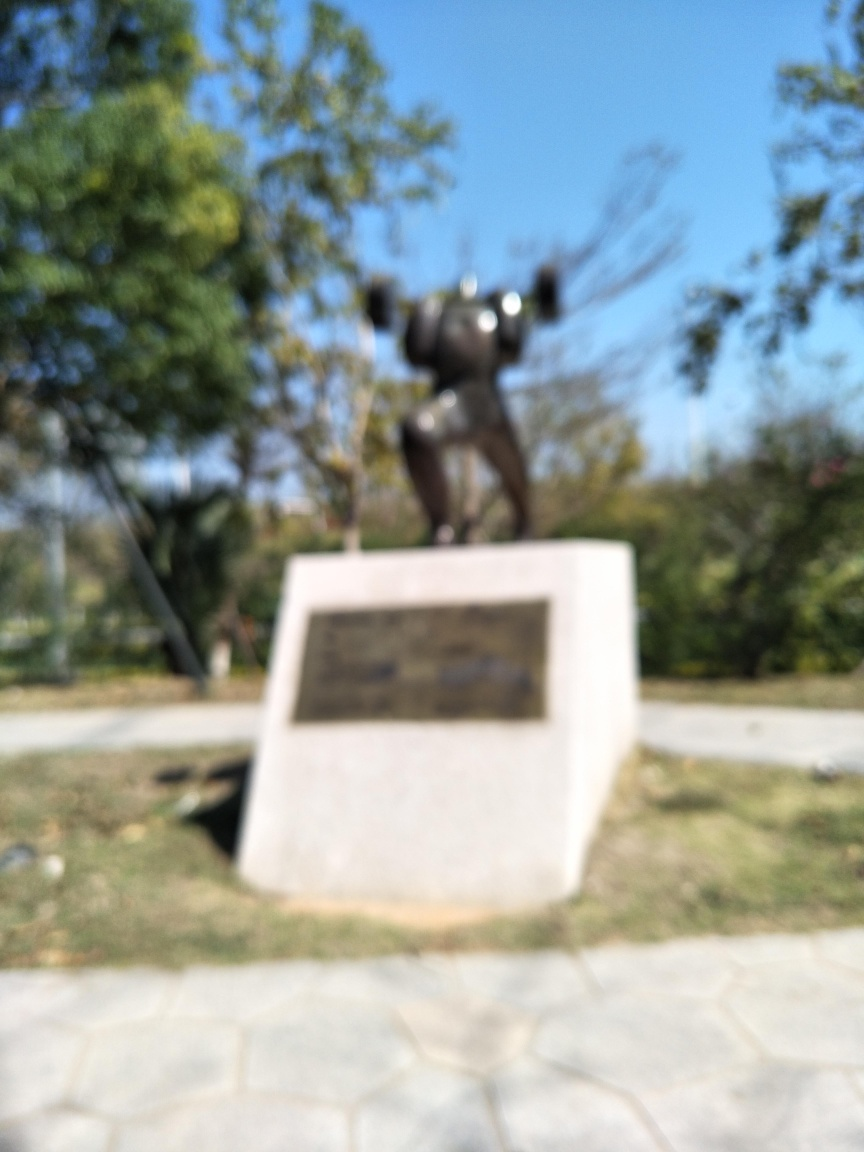Although the image is not clear, can you guess the material of the statue? Based on the silhouette of the object and the way it reflects light, one might infer that the statue is made from a material with a reflective surface, potentially metal. The overall shape suggests it could be a bronze or iron sculpture, which are common materials for outdoor statues. Given the blurriness, is there anything that can be said about the time of day this photo was taken? Despite the lack of clarity, the brightly lit setting and the absence of long shadows suggest that the photograph might have been taken during the midday when the sun is higher in the sky, resulting in more diffuse shadows. 